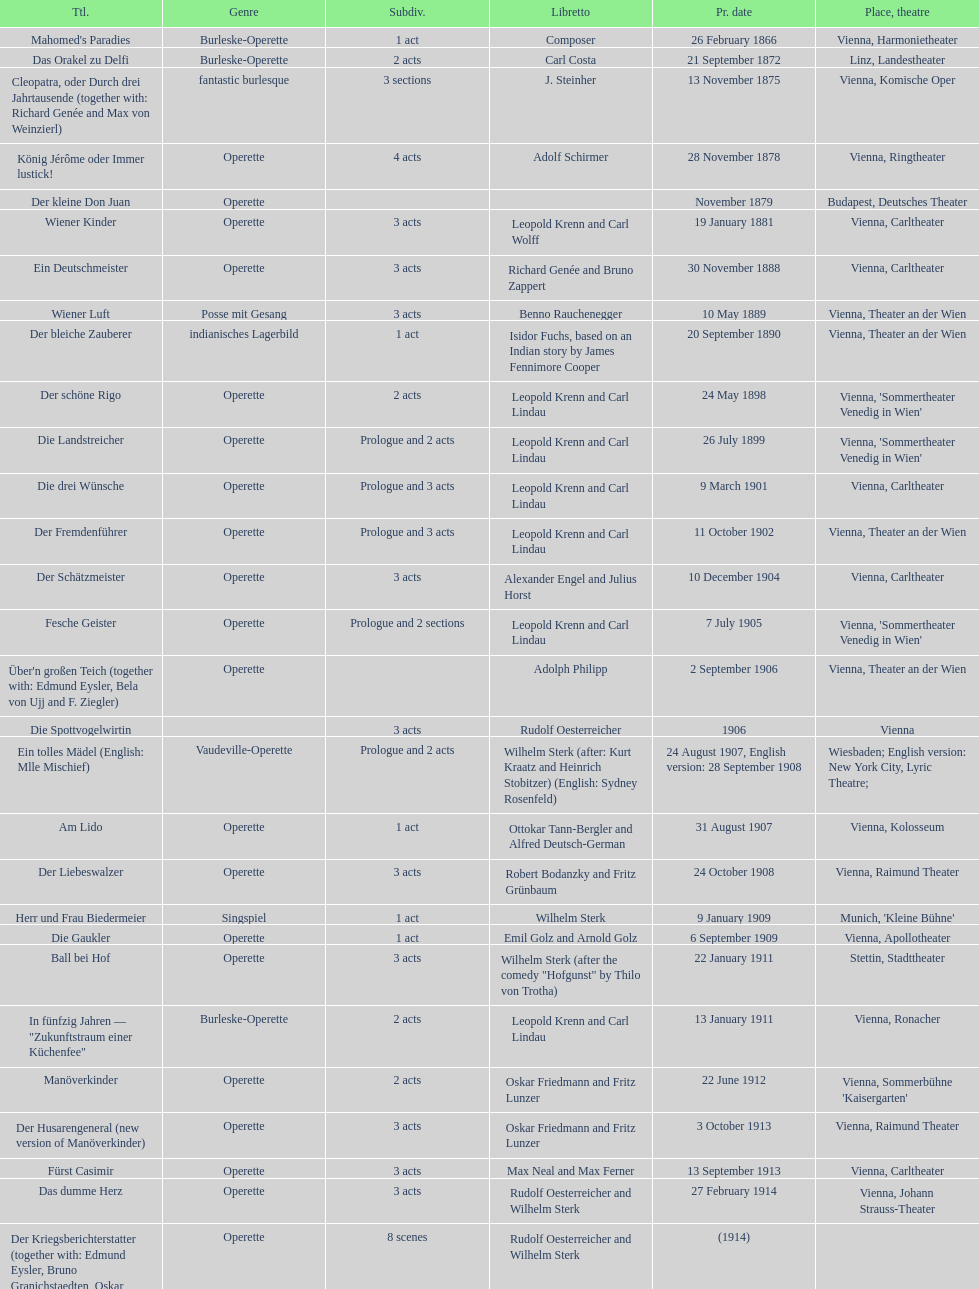What was the year of the last title? 1958. 